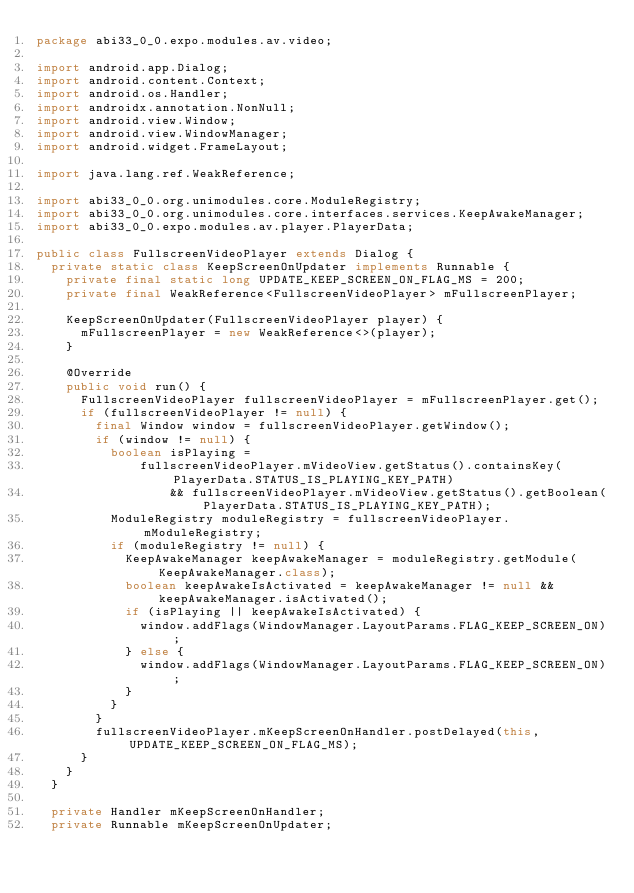Convert code to text. <code><loc_0><loc_0><loc_500><loc_500><_Java_>package abi33_0_0.expo.modules.av.video;

import android.app.Dialog;
import android.content.Context;
import android.os.Handler;
import androidx.annotation.NonNull;
import android.view.Window;
import android.view.WindowManager;
import android.widget.FrameLayout;

import java.lang.ref.WeakReference;

import abi33_0_0.org.unimodules.core.ModuleRegistry;
import abi33_0_0.org.unimodules.core.interfaces.services.KeepAwakeManager;
import abi33_0_0.expo.modules.av.player.PlayerData;

public class FullscreenVideoPlayer extends Dialog {
  private static class KeepScreenOnUpdater implements Runnable {
    private final static long UPDATE_KEEP_SCREEN_ON_FLAG_MS = 200;
    private final WeakReference<FullscreenVideoPlayer> mFullscreenPlayer;

    KeepScreenOnUpdater(FullscreenVideoPlayer player) {
      mFullscreenPlayer = new WeakReference<>(player);
    }

    @Override
    public void run() {
      FullscreenVideoPlayer fullscreenVideoPlayer = mFullscreenPlayer.get();
      if (fullscreenVideoPlayer != null) {
        final Window window = fullscreenVideoPlayer.getWindow();
        if (window != null) {
          boolean isPlaying =
              fullscreenVideoPlayer.mVideoView.getStatus().containsKey(PlayerData.STATUS_IS_PLAYING_KEY_PATH)
                  && fullscreenVideoPlayer.mVideoView.getStatus().getBoolean(PlayerData.STATUS_IS_PLAYING_KEY_PATH);
          ModuleRegistry moduleRegistry = fullscreenVideoPlayer.mModuleRegistry;
          if (moduleRegistry != null) {
            KeepAwakeManager keepAwakeManager = moduleRegistry.getModule(KeepAwakeManager.class);
            boolean keepAwakeIsActivated = keepAwakeManager != null && keepAwakeManager.isActivated();
            if (isPlaying || keepAwakeIsActivated) {
              window.addFlags(WindowManager.LayoutParams.FLAG_KEEP_SCREEN_ON);
            } else {
              window.addFlags(WindowManager.LayoutParams.FLAG_KEEP_SCREEN_ON);
            }
          }
        }
        fullscreenVideoPlayer.mKeepScreenOnHandler.postDelayed(this, UPDATE_KEEP_SCREEN_ON_FLAG_MS);
      }
    }
  }

  private Handler mKeepScreenOnHandler;
  private Runnable mKeepScreenOnUpdater;
</code> 